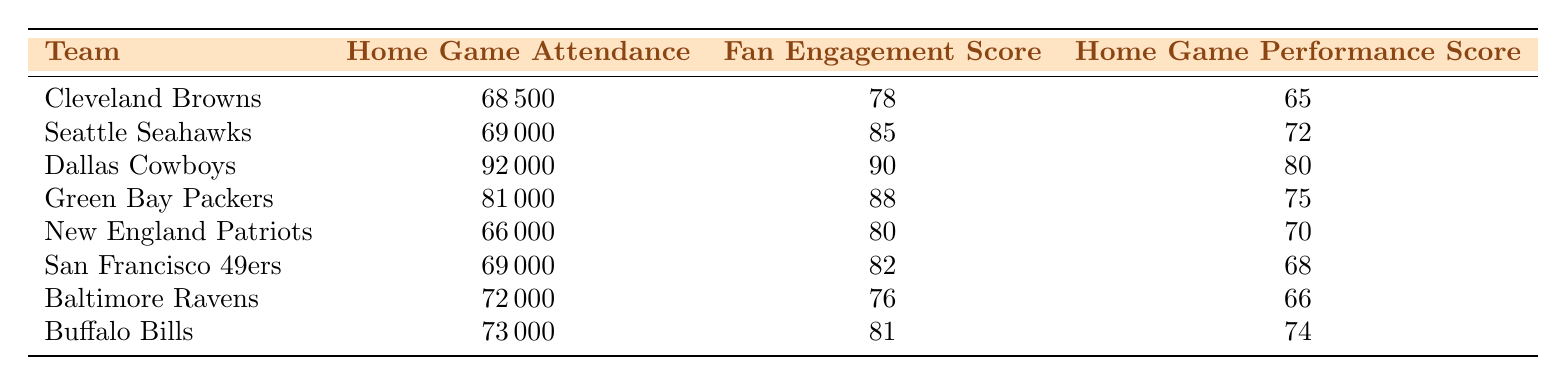What is the home game attendance of the Cleveland Browns? The table states that the home game attendance for the Cleveland Browns is 68,500, as shown in the "Home Game Attendance" column under their row.
Answer: 68,500 Which team has the highest fan engagement score? By reviewing the "Fan Engagement Score" column, the highest score is 90, which belongs to the Dallas Cowboys.
Answer: Dallas Cowboys What is the average home game performance score of the teams listed? To find the average, sum all the home game performance scores: (65 + 72 + 80 + 75 + 70 + 68 + 66 + 74) = 600. There are 8 teams, so the average is 600/8 = 75.
Answer: 75 Is it true that the Baltimore Ravens have a higher home game performance score than the Seattle Seahawks? The table shows that the home game performance score for the Baltimore Ravens is 66 and for the Seattle Seahawks is 72. Since 66 is less than 72, the statement is false.
Answer: No What is the difference in fan engagement scores between the highest and lowest teams? The highest fan engagement score is 90 (Dallas Cowboys) and the lowest is 76 (Baltimore Ravens). The difference is 90 - 76 = 14.
Answer: 14 